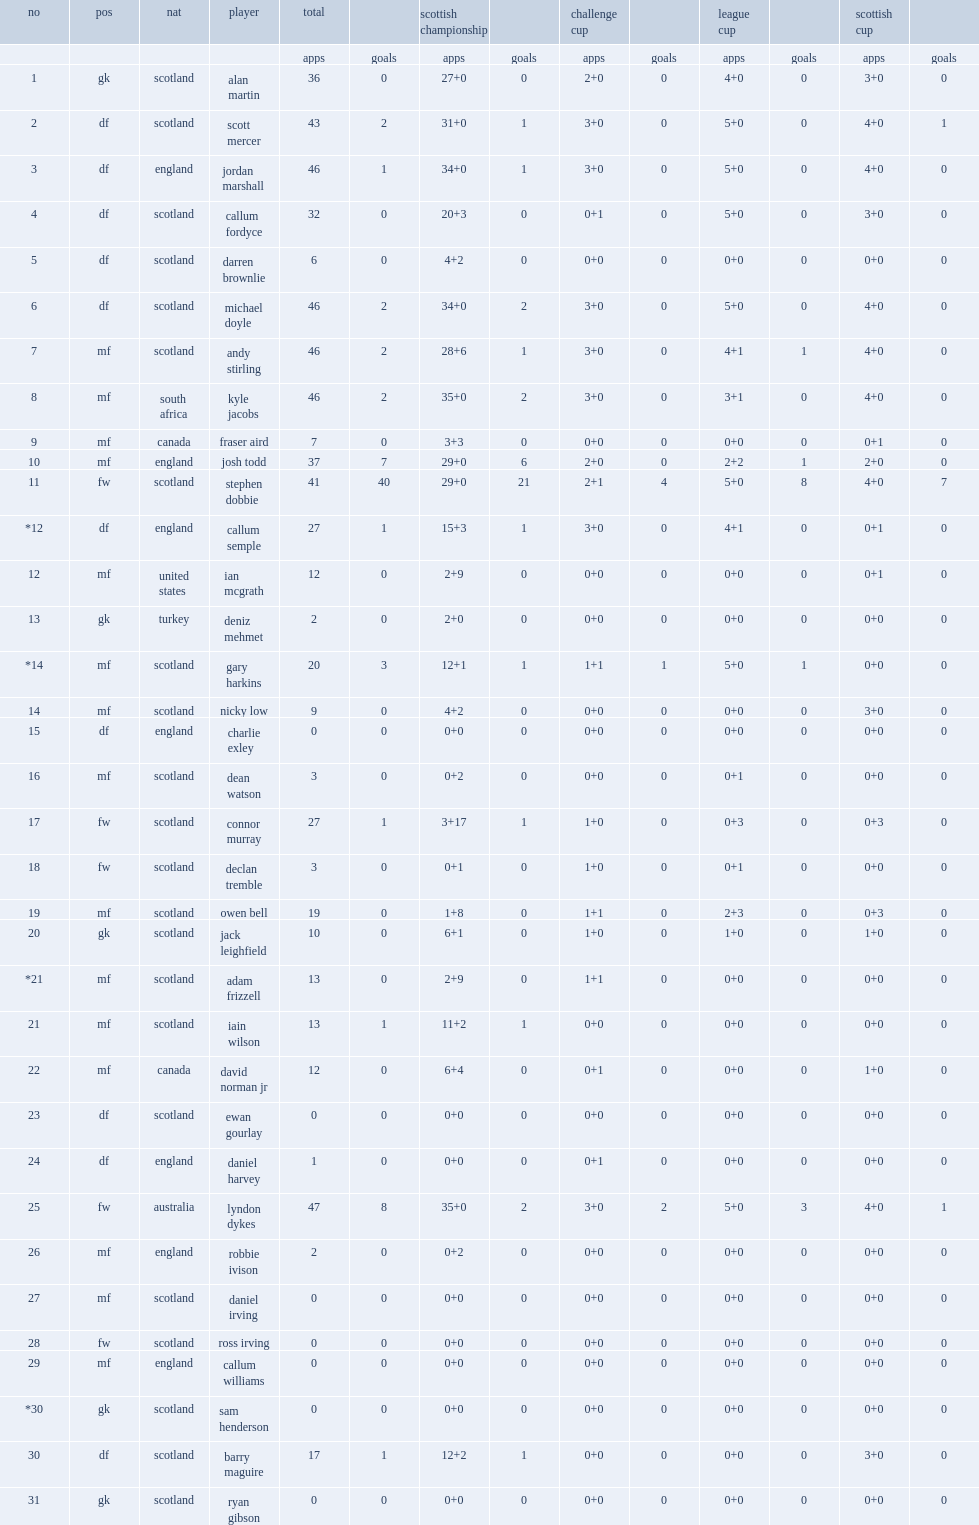What the matches did queens compete in? Challenge cup league cup scottish cup. 